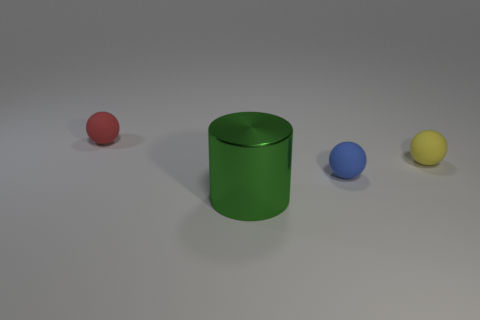Are there any other things that have the same size as the green metal object?
Keep it short and to the point. No. There is a rubber thing that is in front of the ball to the right of the small blue ball; what is its color?
Offer a terse response. Blue. What number of balls are small yellow things or matte objects?
Your answer should be very brief. 3. What number of tiny matte spheres are to the left of the yellow matte sphere and behind the blue ball?
Keep it short and to the point. 1. What color is the object that is to the left of the green metallic cylinder?
Your response must be concise. Red. There is a red object that is made of the same material as the tiny yellow thing; what is its size?
Give a very brief answer. Small. What number of big shiny objects are in front of the small matte object to the left of the green cylinder?
Your response must be concise. 1. How many small spheres are to the left of the big green cylinder?
Make the answer very short. 1. There is a object on the right side of the tiny rubber object in front of the yellow ball that is on the right side of the big green thing; what color is it?
Your answer should be compact. Yellow. Do the object left of the big green object and the tiny matte object that is right of the small blue ball have the same color?
Your answer should be compact. No. 